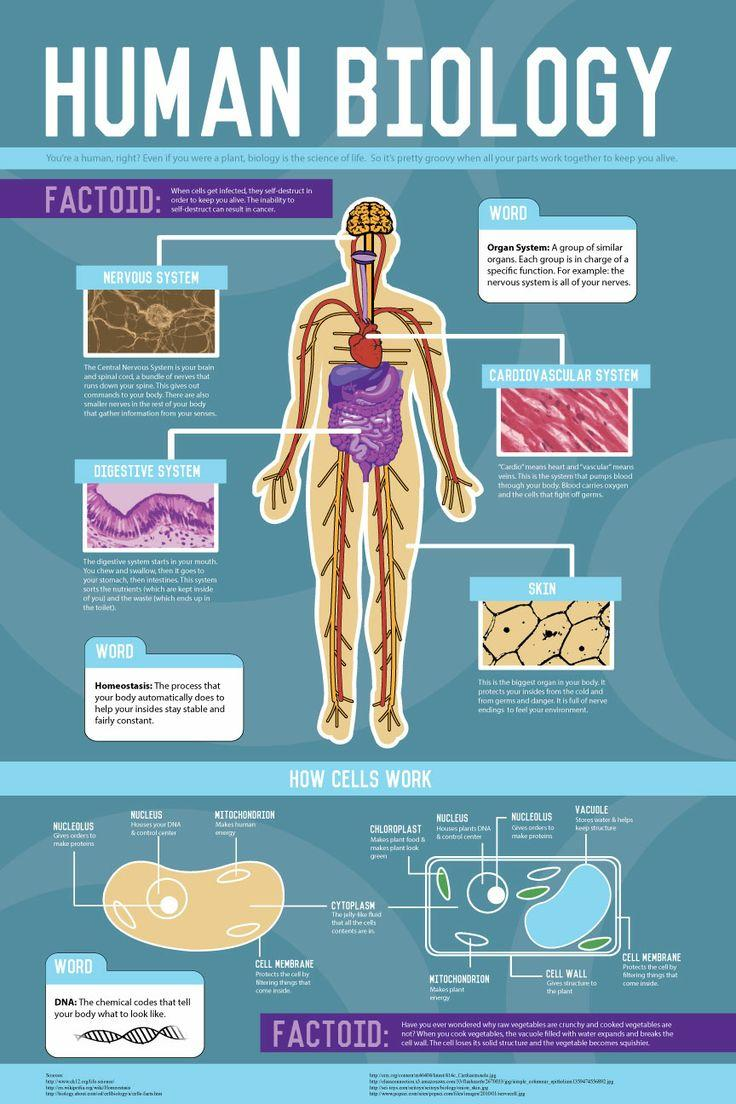Identify some key points in this picture. The diagram shows 4 organ systems. 